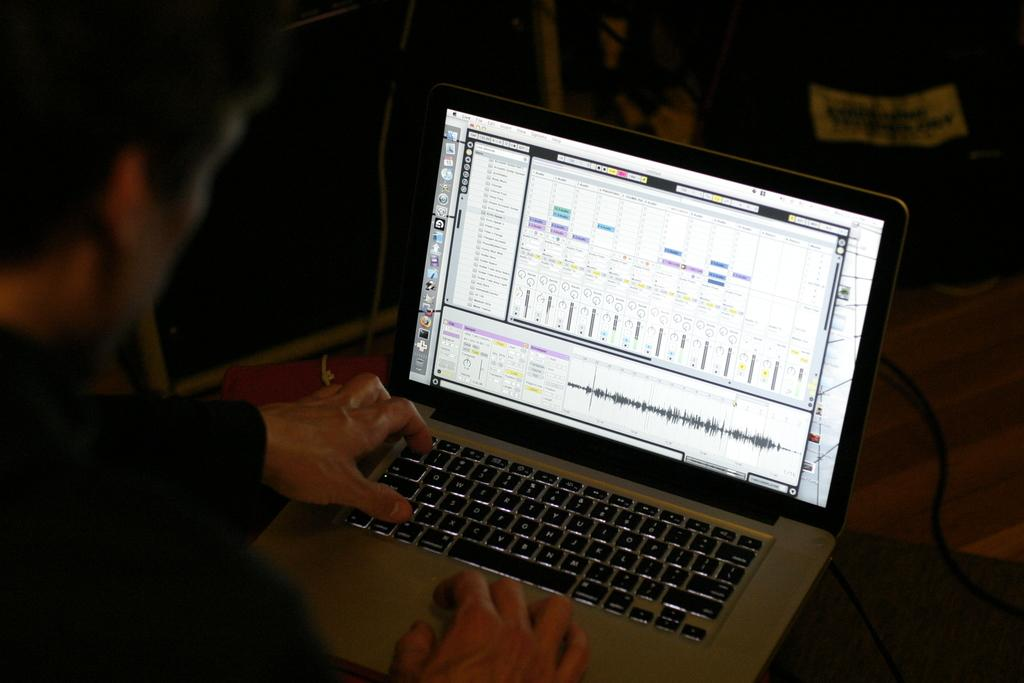What is the main subject of the image? The main subject of the image is a man. What object can be seen near the man? There is a laptop in the image. What else is present in the image besides the man and laptop? Cables are present in the image. How would you describe the overall appearance of the image? The background of the image is dark. What flavor of ice cream does the man in the image prefer? There is no mention of ice cream or any flavor preferences in the image. 